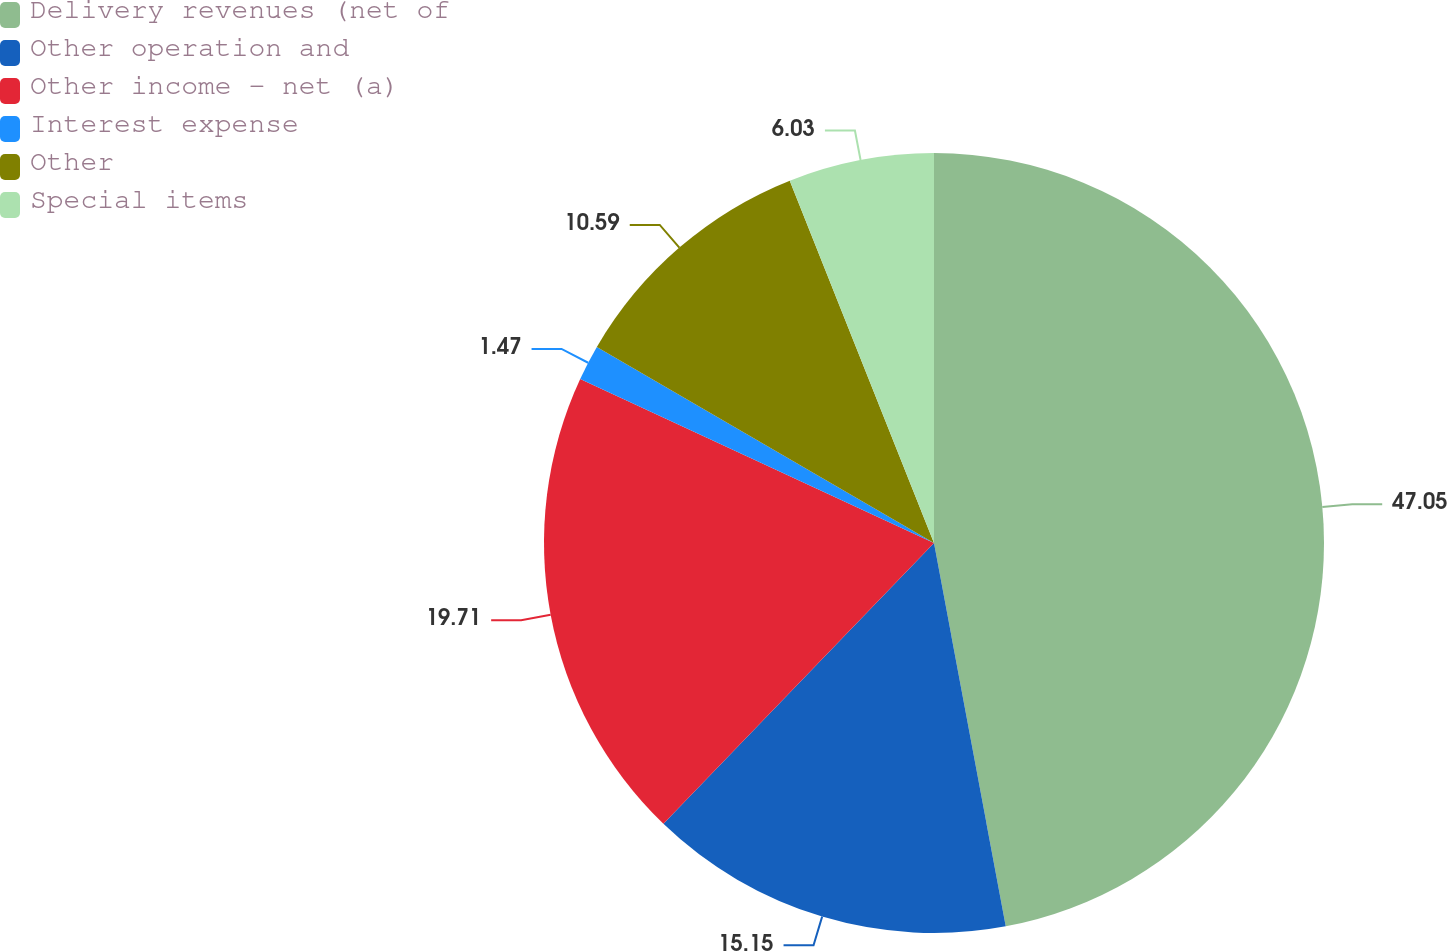Convert chart. <chart><loc_0><loc_0><loc_500><loc_500><pie_chart><fcel>Delivery revenues (net of<fcel>Other operation and<fcel>Other income - net (a)<fcel>Interest expense<fcel>Other<fcel>Special items<nl><fcel>47.06%<fcel>15.15%<fcel>19.71%<fcel>1.47%<fcel>10.59%<fcel>6.03%<nl></chart> 